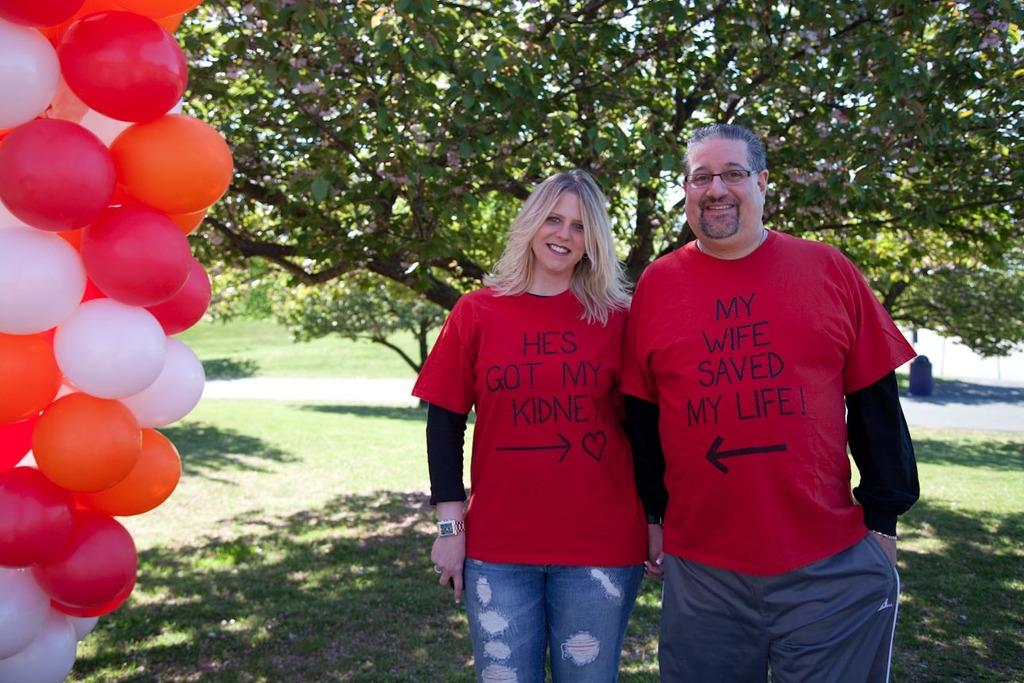What can be seen in the picture? There is a couple in the picture. What are the couple wearing? Both individuals in the couple are wearing red T-shirts. What is the couple's expression? The couple is smiling. What is on the left side of the image? There are balloons on the left side of the image. What can be seen in the background of the image? There is a tree in the background of the image. What is the title of the couple's favorite book, as seen in the image? There is no book or title visible in the image. What scent is associated with the couple in the image? There is no mention of a scent in the image. 